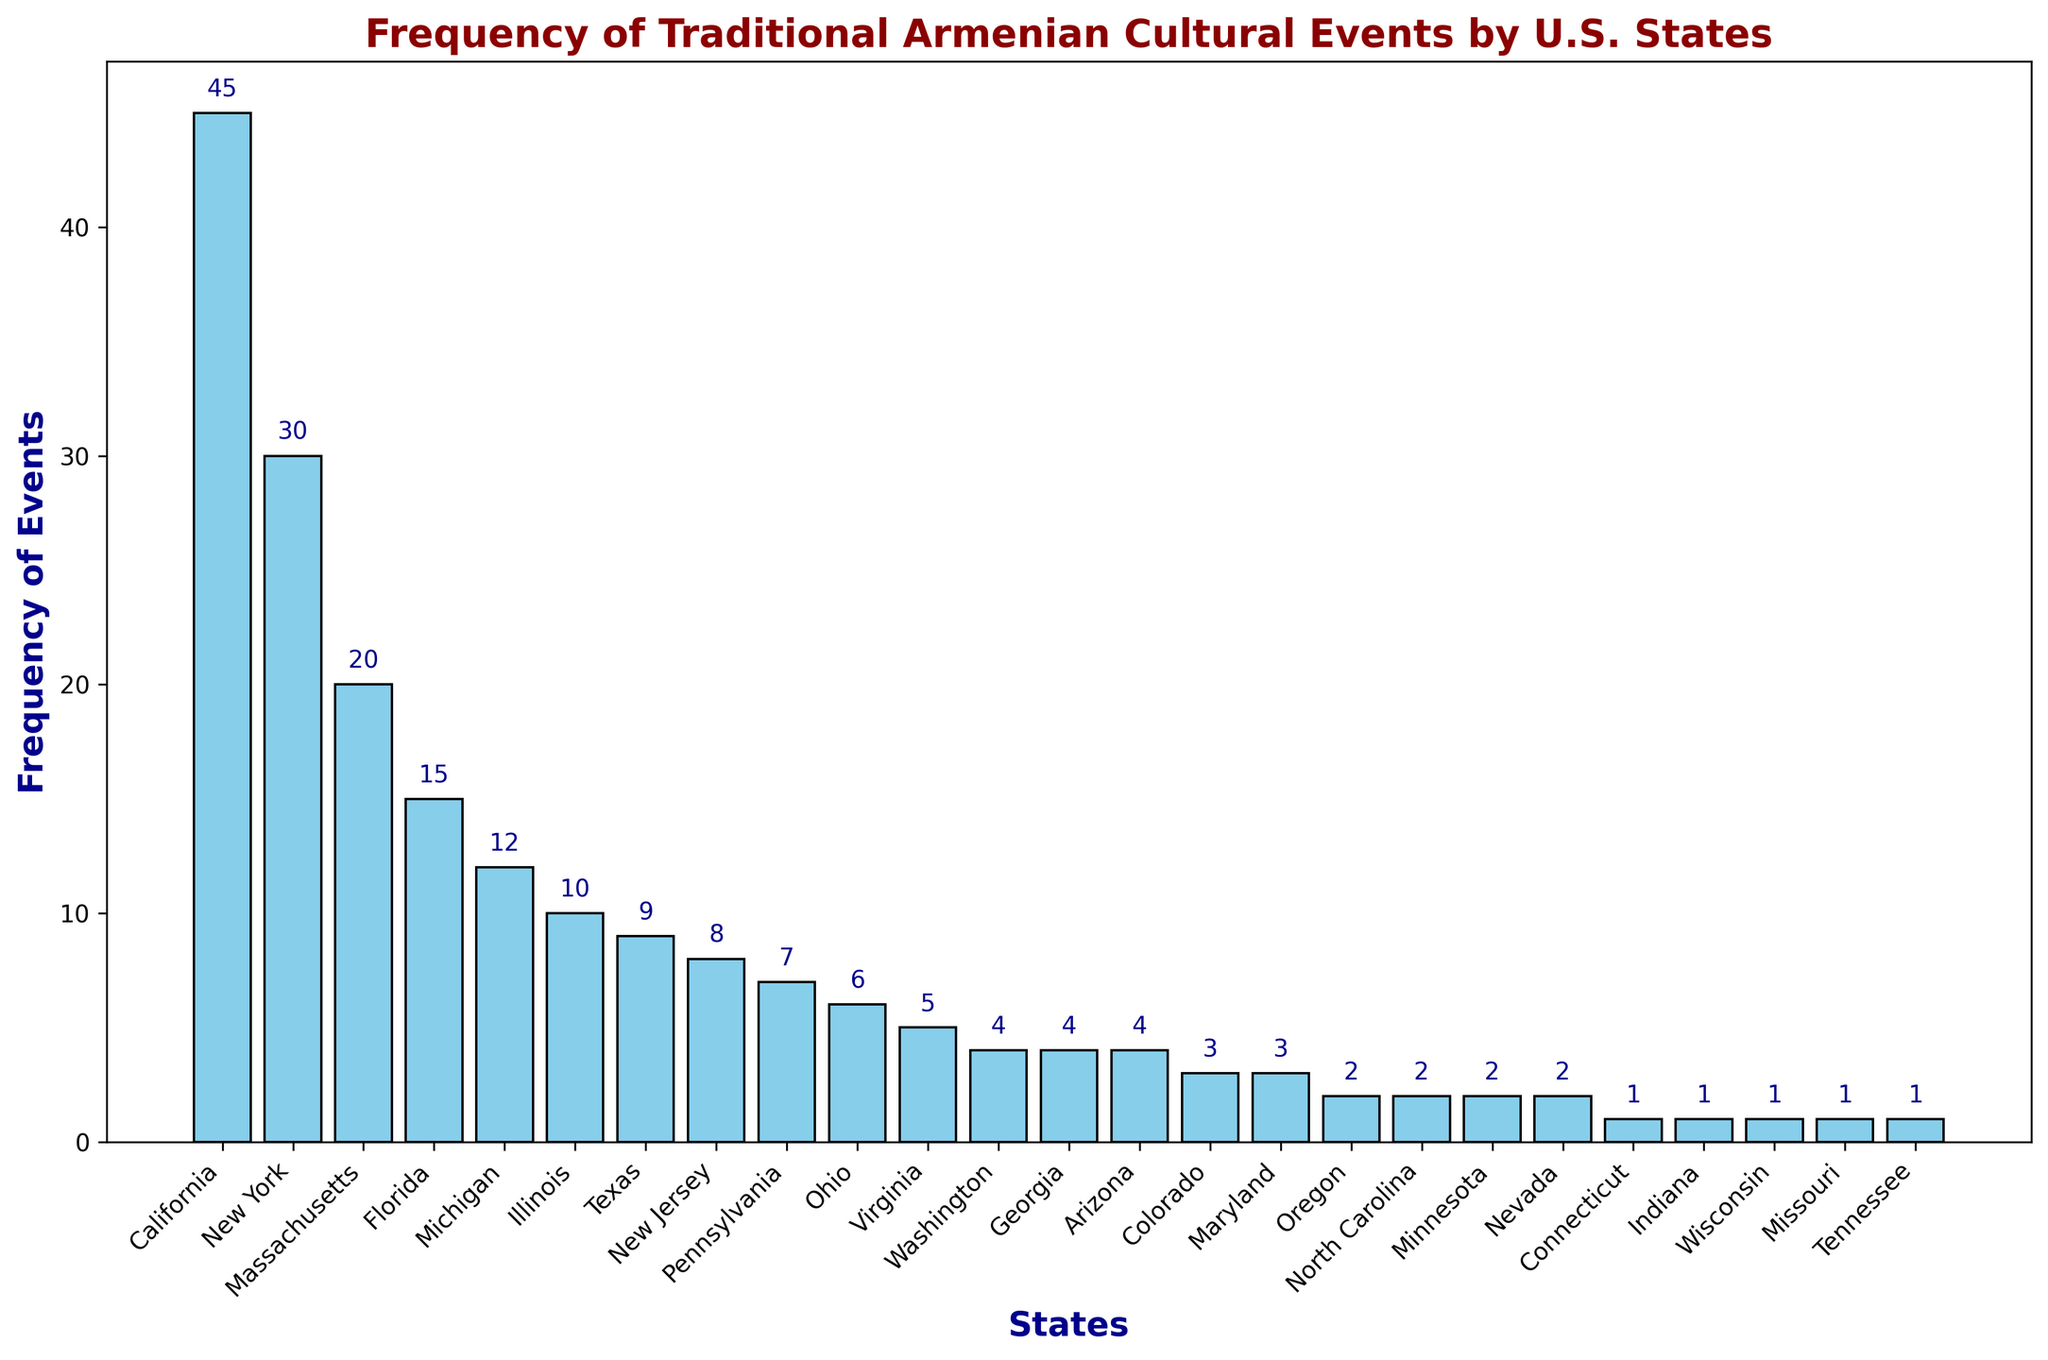what state has the highest frequency of cultural events? By looking at the height of the bars, California has the tallest bar, indicating it has the highest frequency.
Answer: California Which state has the lowest frequency of cultural events? The shortest bars represent the lowest frequencies. Connecticut, Indiana, Wisconsin, Missouri, and Tennessee all have the smallest bars with a frequency of 1.
Answer: Connecticut, Indiana, Wisconsin, Missouri, Tennessee What's the total frequency of events in New York, Florida, and Virginia combined? Add the frequencies from the respective states: New York (30), Florida (15), and Virginia (5). The sum is 30 + 15 + 5 = 50.
Answer: 50 Is the frequency of events in California more than double that in New York? California has a frequency of 45, and New York has 30. Doubling New York's frequency gives 60, which is greater than 45, so California's frequency is not more than double that in New York.
Answer: No Comparing Massachusetts and Michigan, which state has more events and by how much? Massachusetts has a frequency of 20 and Michigan has 12. Subtract Michigan's frequency from Massachusetts' frequency: 20 - 12 = 8. Massachusetts has 8 more events.
Answer: Massachusetts, 8 What visual feature represents the frequency of cultural events in each state? The height of the bars represents the frequency of cultural events in each state, with taller bars indicating higher frequencies.
Answer: Height of bars How many states have a frequency greater than 10? States with frequencies greater than 10 are California (45), New York (30), Massachusetts (20), Florida (15), and Michigan (12). Counting these states, we get 5.
Answer: 5 If you add the frequencies of events in Washington, Georgia, and Arizona, what do you get? Is this more or less than the frequency in Texas? Washington (4), Georgia (4), and Arizona (4) each have frequencies of 4. Adding them gives 4 + 4 + 4 = 12, which is more than Texas (9).
Answer: 12, more Among New Jersey, Pennsylvania, and Ohio, which state has the least number of events? New Jersey has a frequency of 8, Pennsylvania has 7, and Ohio has 6. Ohio has the least number of events.
Answer: Ohio 